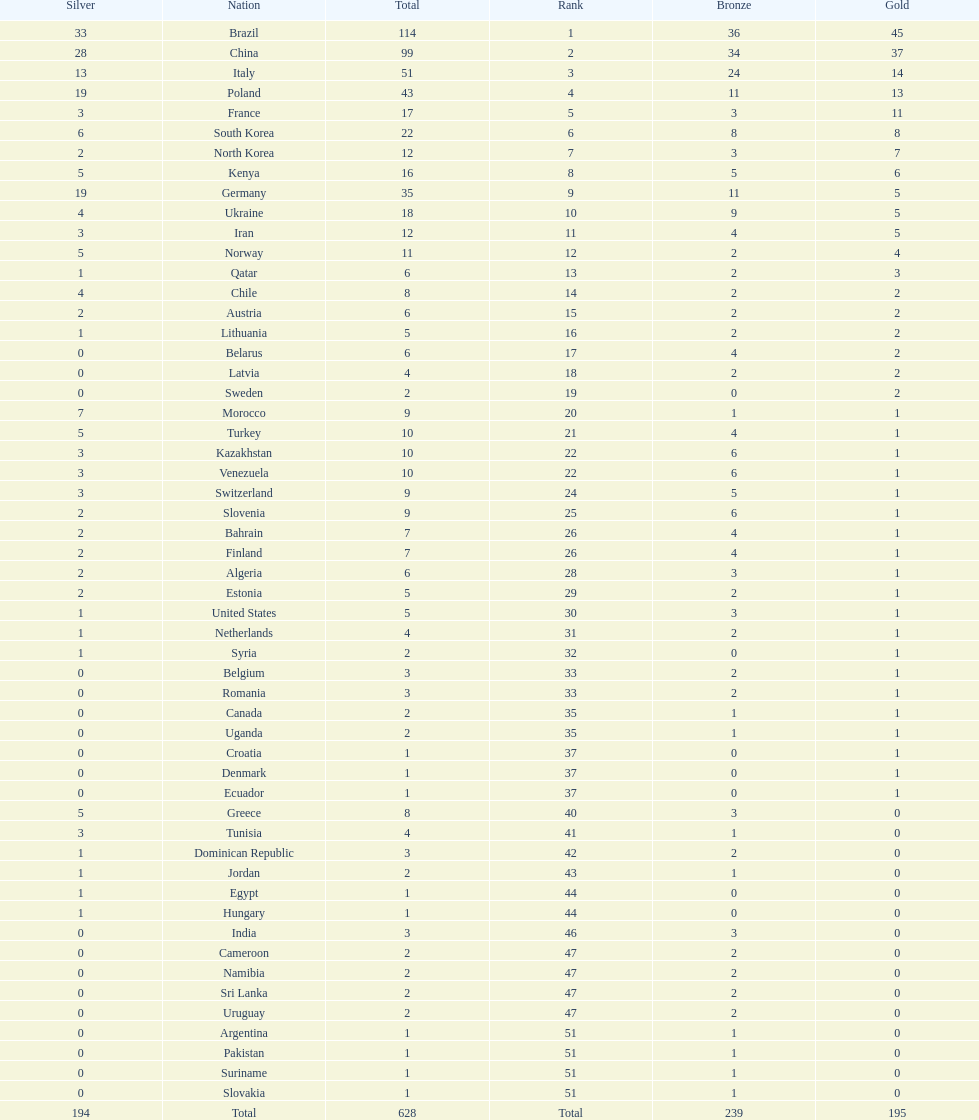How many gold medals did germany earn? 5. 